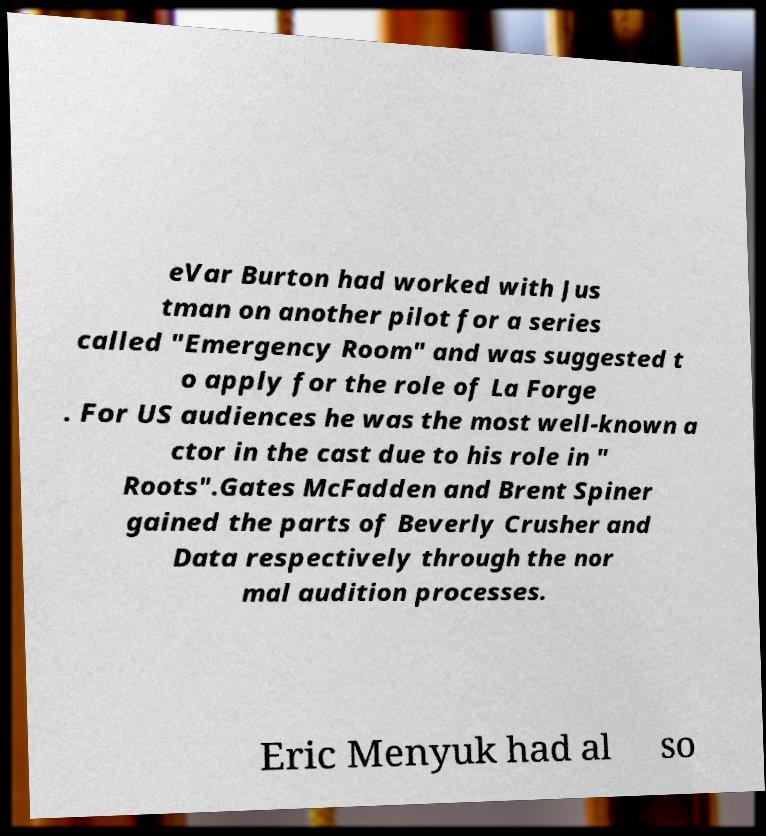Can you read and provide the text displayed in the image?This photo seems to have some interesting text. Can you extract and type it out for me? eVar Burton had worked with Jus tman on another pilot for a series called "Emergency Room" and was suggested t o apply for the role of La Forge . For US audiences he was the most well-known a ctor in the cast due to his role in " Roots".Gates McFadden and Brent Spiner gained the parts of Beverly Crusher and Data respectively through the nor mal audition processes. Eric Menyuk had al so 